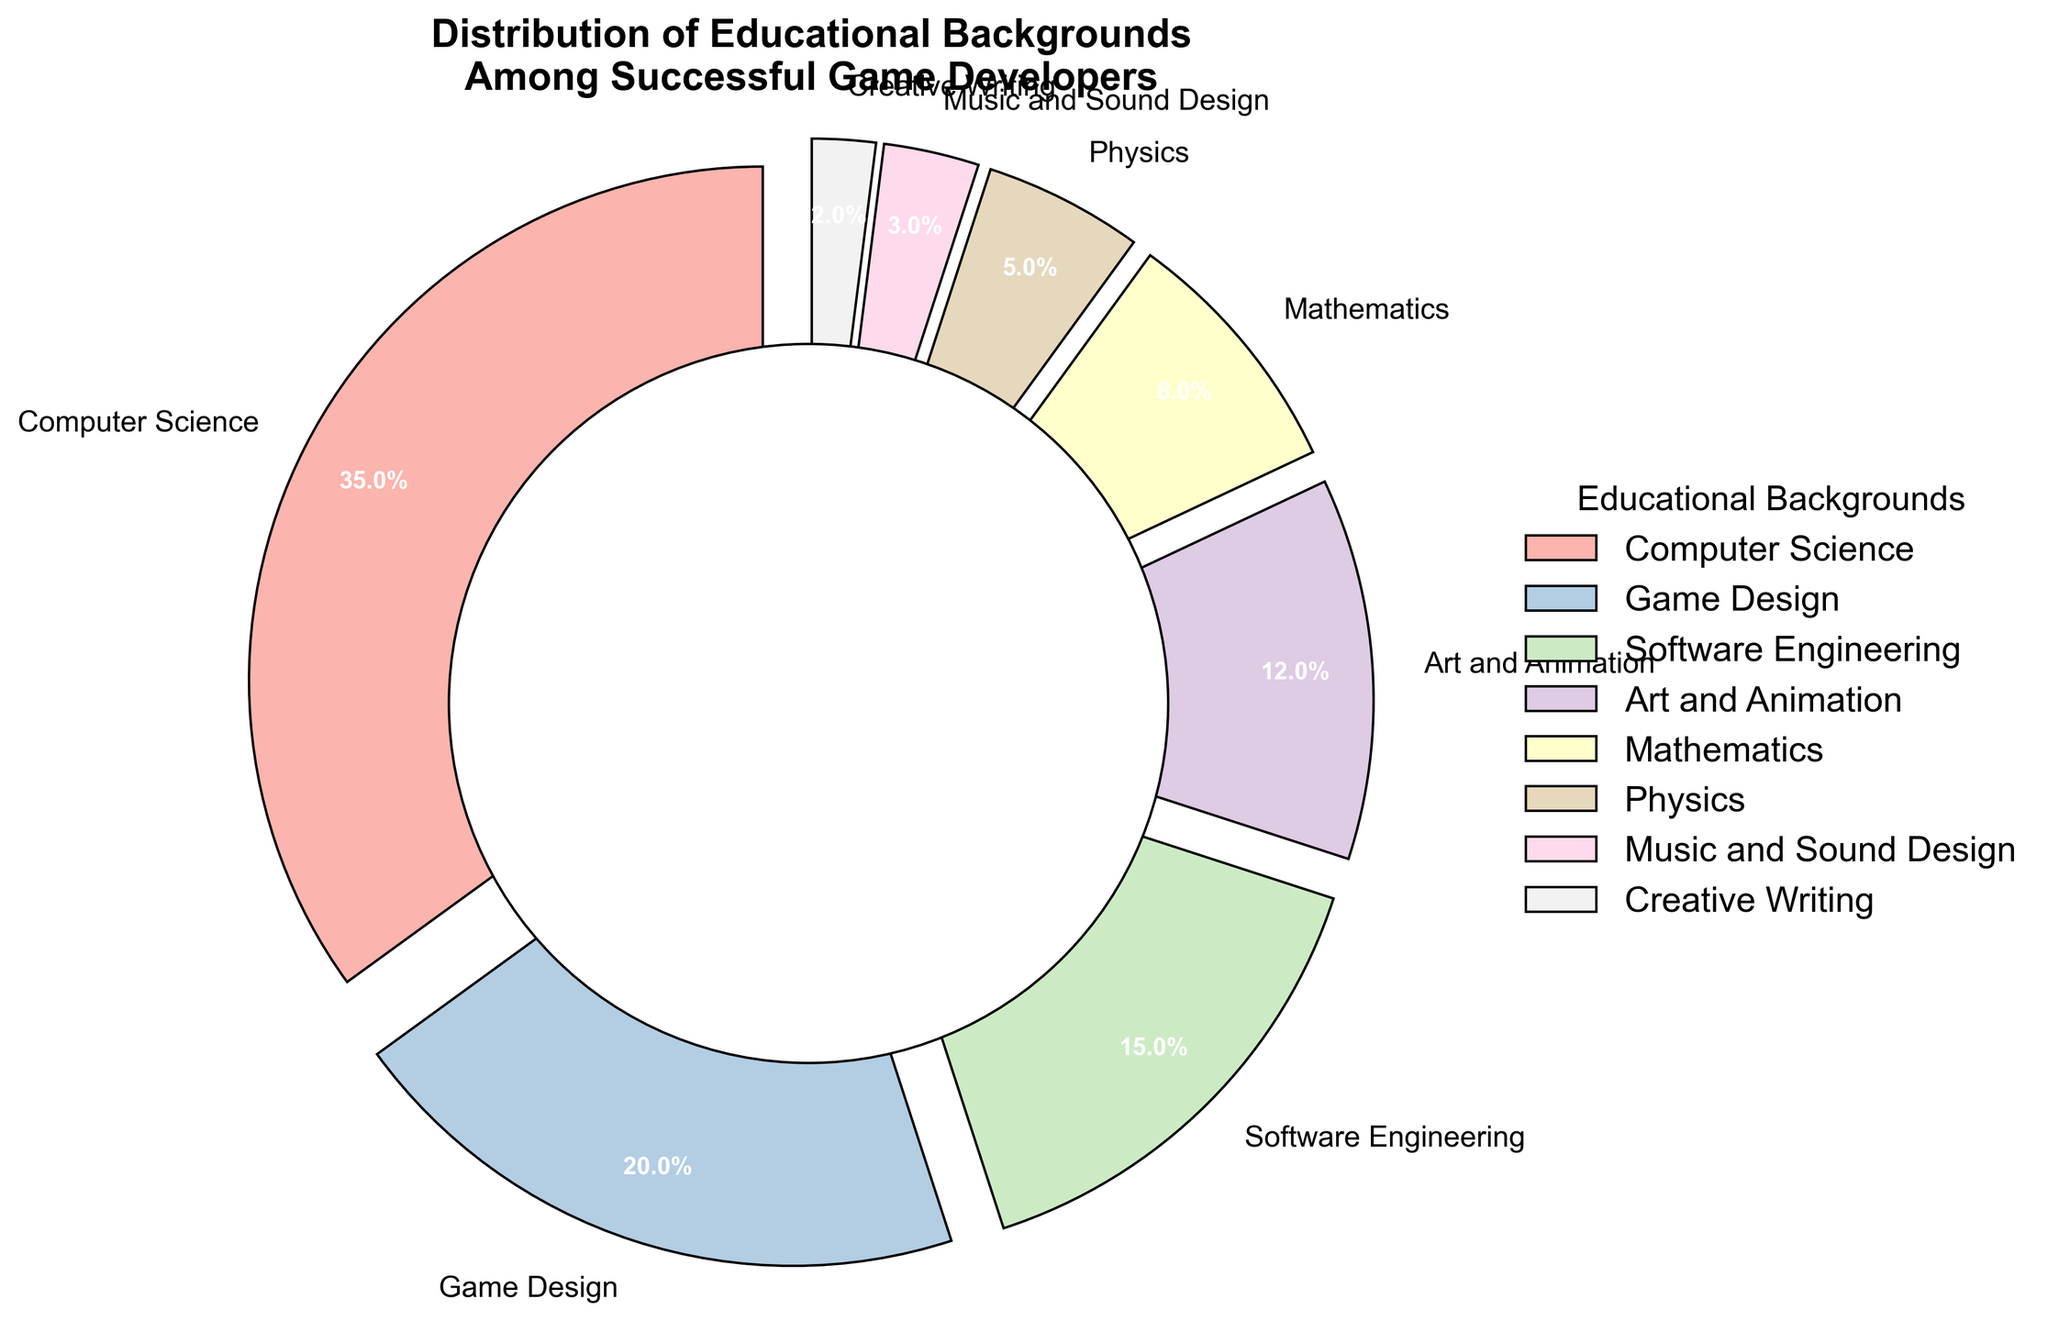What percentage of successful game developers have a background in Computer Science? The percentage of game developers with a background in Computer Science can be directly read from the chart, where it is labeled.
Answer: 35% Which educational background forms the smallest segment in the chart? The smallest percentage is represented by the segment with the label "Creative Writing."
Answer: Creative Writing Are there more game developers with backgrounds in Art and Animation or Mathematics, and by how much? The chart shows that Art and Animation has 12%, while Mathematics has 8%. Subtracting the two gives 12% - 8% = 4%.
Answer: Art and Animation by 4% What is the combined percentage of game developers with backgrounds in Software Engineering, Physics, and Creative Writing? Add the percentages from the labels: Software Engineering (15%) + Physics (5%) + Creative Writing (2%) = 15% + 5% + 2% = 22%.
Answer: 22% If you combine the percentages of game developers with backgrounds in Game Design and Music and Sound Design, is the sum more or less than the percentage of those with a background in Computer Science? Game Design is 20%, and Music and Sound Design is 3%. Adding these gives 20% + 3% = 23%. The percentage for Computer Science is 35%, so it is more.
Answer: Less What percentage of educational backgrounds are not from a technical field (Computer Science, Software Engineering, Mathematics, Physics)? The percentage of non-technical fields can be found by summing up the non-technical fields: Game Design (20%), Art and Animation (12%), Music and Sound Design (3%), Creative Writing (2%) = 20% + 12% + 3% + 2% = 37%.
Answer: 37% How many different educational backgrounds are presented in the chart? Count the number of unique labels in the pie chart: Computer Science, Game Design, Software Engineering, Art and Animation, Mathematics, Physics, Music and Sound Design, Creative Writing. This results in a total of 8 different backgrounds.
Answer: 8 Is the percentage of game developers with an Art and Animation background more or less than half of those with a Computer Science background? The percentage with Art and Animation is 12%, and half of the Computer Science percentage is 35% / 2 = 17.5%. Since 12% is less than 17.5%, it is less.
Answer: Less 